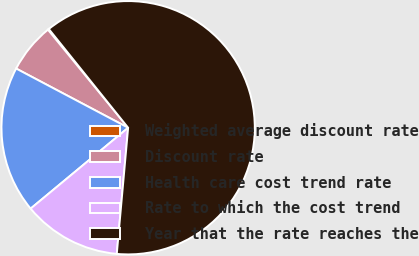<chart> <loc_0><loc_0><loc_500><loc_500><pie_chart><fcel>Weighted average discount rate<fcel>Discount rate<fcel>Health care cost trend rate<fcel>Rate to which the cost trend<fcel>Year that the rate reaches the<nl><fcel>0.14%<fcel>6.35%<fcel>18.76%<fcel>12.55%<fcel>62.2%<nl></chart> 